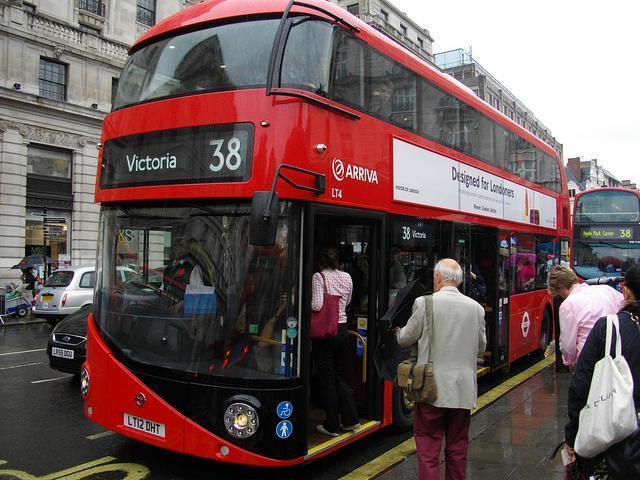How many people are in the picture?
Give a very brief answer. 4. How many buses can you see?
Give a very brief answer. 2. How many handbags can you see?
Give a very brief answer. 1. How many cars are in the picture?
Give a very brief answer. 2. How many people are standing outside the train in the image?
Give a very brief answer. 0. 